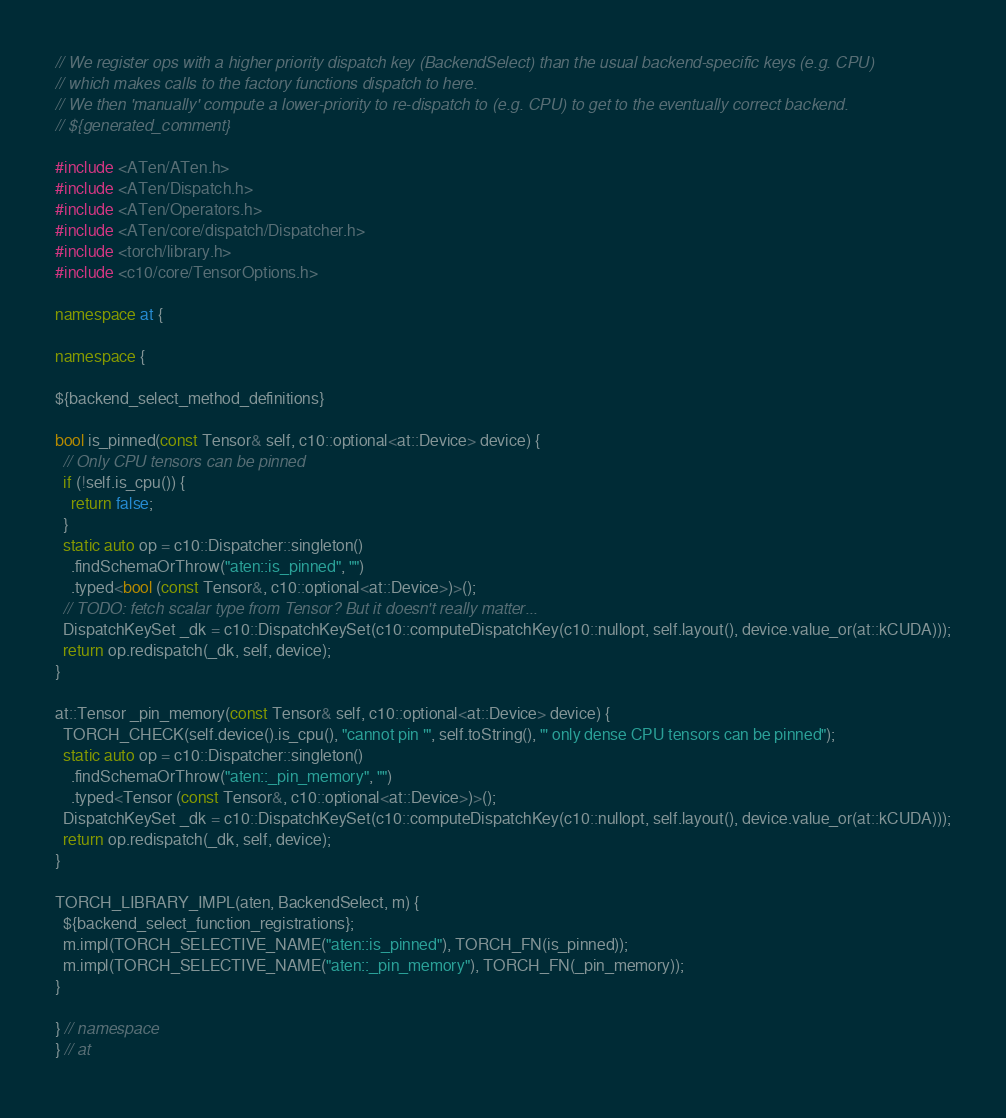Convert code to text. <code><loc_0><loc_0><loc_500><loc_500><_C++_>// We register ops with a higher priority dispatch key (BackendSelect) than the usual backend-specific keys (e.g. CPU)
// which makes calls to the factory functions dispatch to here.
// We then 'manually' compute a lower-priority to re-dispatch to (e.g. CPU) to get to the eventually correct backend.
// ${generated_comment}

#include <ATen/ATen.h>
#include <ATen/Dispatch.h>
#include <ATen/Operators.h>
#include <ATen/core/dispatch/Dispatcher.h>
#include <torch/library.h>
#include <c10/core/TensorOptions.h>

namespace at {

namespace {

${backend_select_method_definitions}

bool is_pinned(const Tensor& self, c10::optional<at::Device> device) {
  // Only CPU tensors can be pinned
  if (!self.is_cpu()) {
    return false;
  }
  static auto op = c10::Dispatcher::singleton()
    .findSchemaOrThrow("aten::is_pinned", "")
    .typed<bool (const Tensor&, c10::optional<at::Device>)>();
  // TODO: fetch scalar type from Tensor? But it doesn't really matter...
  DispatchKeySet _dk = c10::DispatchKeySet(c10::computeDispatchKey(c10::nullopt, self.layout(), device.value_or(at::kCUDA)));
  return op.redispatch(_dk, self, device);
}

at::Tensor _pin_memory(const Tensor& self, c10::optional<at::Device> device) {
  TORCH_CHECK(self.device().is_cpu(), "cannot pin '", self.toString(), "' only dense CPU tensors can be pinned");
  static auto op = c10::Dispatcher::singleton()
    .findSchemaOrThrow("aten::_pin_memory", "")
    .typed<Tensor (const Tensor&, c10::optional<at::Device>)>();
  DispatchKeySet _dk = c10::DispatchKeySet(c10::computeDispatchKey(c10::nullopt, self.layout(), device.value_or(at::kCUDA)));
  return op.redispatch(_dk, self, device);
}

TORCH_LIBRARY_IMPL(aten, BackendSelect, m) {
  ${backend_select_function_registrations};
  m.impl(TORCH_SELECTIVE_NAME("aten::is_pinned"), TORCH_FN(is_pinned));
  m.impl(TORCH_SELECTIVE_NAME("aten::_pin_memory"), TORCH_FN(_pin_memory));
}

} // namespace
} // at
</code> 